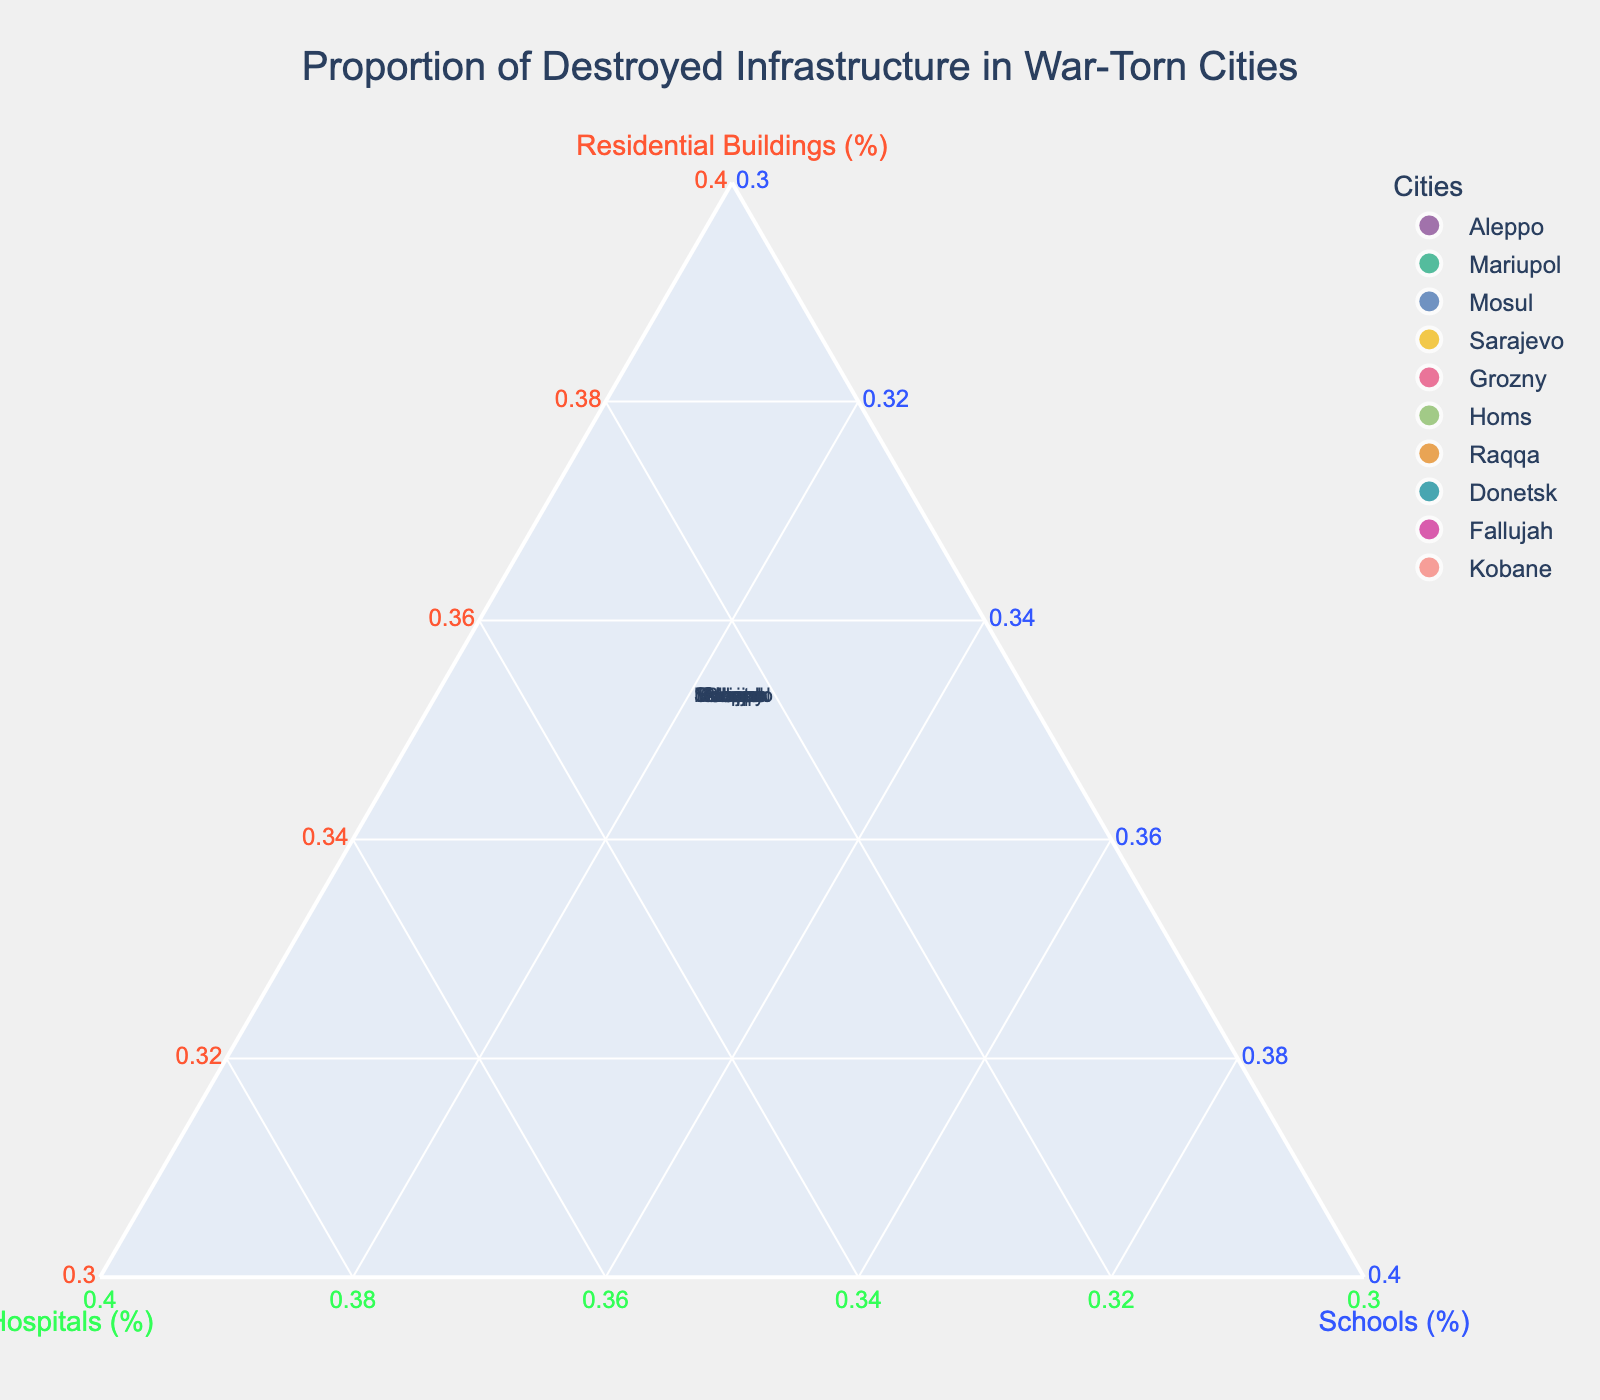What's the title of the figure? The title is usually placed at the top of the plot and is designed to succinctly convey the main subject of the figure.
Answer: Proportion of Destroyed Infrastructure in War-Torn Cities How many cities are represented in the plot? Each city is a data point in the ternary plot, and each point corresponds to a city from the data provided.
Answer: 10 Which city has the highest proportion of destroyed residential buildings? Look at the ternary plot and identify the point that is highest along the axis labeled "Residential Buildings (%)". Hovering over each point may also help to see the detailed proportions.
Answer: Mariupol Which two cities have the closest proportions of destroyed infrastructure types? Identify the points that are closest to each other in the ternary plot, indicating similar proportions across all three categories (residential buildings, hospitals, schools).
Answer: Raqqa and Kobane Which city has the smallest proportion of destroyed hospitals? Find the data point lowest along the "Hospitals (%)" axis. Hovering might be useful if proportions are not visually clear.
Answer: Grozny What is the approximate proportion of destroyed schools in Sarajevo? Look at the position of Sarajevo in the ternary plot relative to the "Schools (%)" axis to approximate its value.
Answer: 33% Compare the proportions of destroyed infrastructure in Donetsk and Fallujah. Which has more destroyed schools? Examine the relative positions of Donetsk and Fallujah points along the "Schools (%)" axis.
Answer: Fallujah Between which types of destroyed infrastructures (residential buildings, hospitals, schools) does Kobane have the highest variation? Examine the proportion values for Kobane in the three categories and determine the differences (variation) between them.
Answer: Schools vs. Residential Buildings Which city lies closest to the center of the ternary plot, indicating a near-equal proportion of destroyed infrastructure types? Locate the data point closest to the center (where proportions are roughly equal in all three categories).
Answer: Sarajevo 